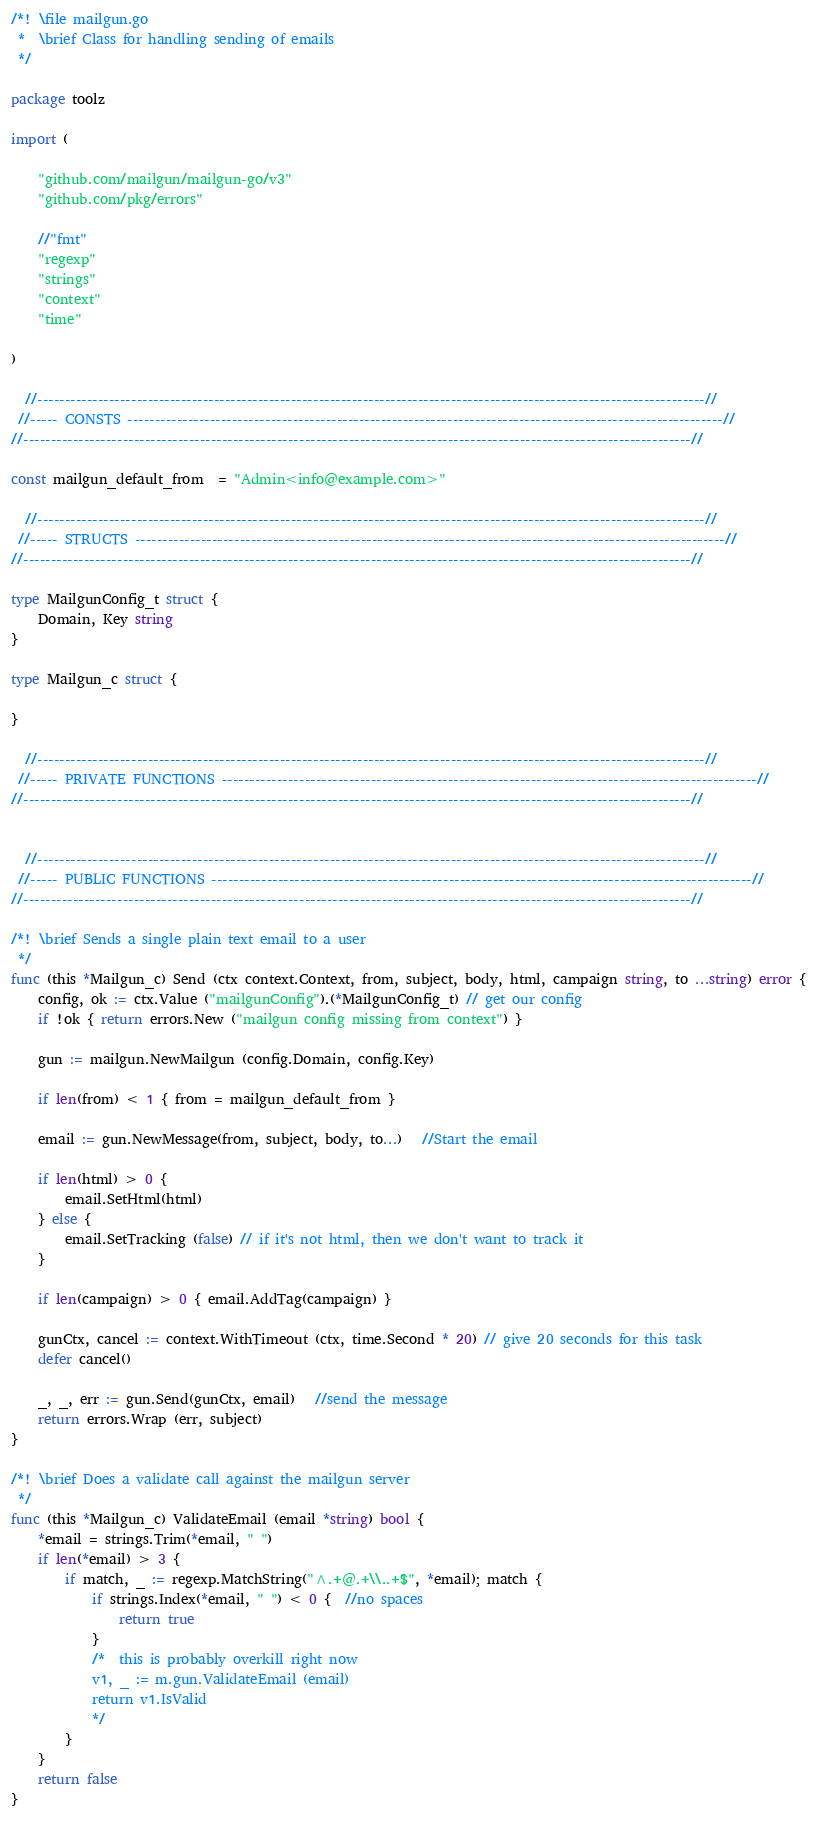Convert code to text. <code><loc_0><loc_0><loc_500><loc_500><_Go_>/*! \file mailgun.go
 *  \brief Class for handling sending of emails
 */

package toolz

import (

	"github.com/mailgun/mailgun-go/v3"
	"github.com/pkg/errors"

    //"fmt"
    "regexp"
	"strings"
	"context"
    "time"
    
)

  //-------------------------------------------------------------------------------------------------------------------------//
 //----- CONSTS ------------------------------------------------------------------------------------------------------------//
//-------------------------------------------------------------------------------------------------------------------------//

const mailgun_default_from  = "Admin<info@example.com>"

  //-------------------------------------------------------------------------------------------------------------------------//
 //----- STRUCTS -----------------------------------------------------------------------------------------------------------//
//-------------------------------------------------------------------------------------------------------------------------//

type MailgunConfig_t struct {
	Domain, Key string
}

type Mailgun_c struct {
    
}

  //-------------------------------------------------------------------------------------------------------------------------//
 //----- PRIVATE FUNCTIONS -------------------------------------------------------------------------------------------------//
//-------------------------------------------------------------------------------------------------------------------------//


  //-------------------------------------------------------------------------------------------------------------------------//
 //----- PUBLIC FUNCTIONS --------------------------------------------------------------------------------------------------//
//-------------------------------------------------------------------------------------------------------------------------//

/*! \brief Sends a single plain text email to a user
 */
func (this *Mailgun_c) Send (ctx context.Context, from, subject, body, html, campaign string, to ...string) error {
	config, ok := ctx.Value ("mailgunConfig").(*MailgunConfig_t) // get our config
	if !ok { return errors.New ("mailgun config missing from context") }

	gun := mailgun.NewMailgun (config.Domain, config.Key)

    if len(from) < 1 { from = mailgun_default_from }
    
	email := gun.NewMessage(from, subject, body, to...)   //Start the email
	
	if len(html) > 0 { 
		email.SetHtml(html) 
	} else {
		email.SetTracking (false) // if it's not html, then we don't want to track it
	}
    
	if len(campaign) > 0 { email.AddTag(campaign) }
	
	gunCtx, cancel := context.WithTimeout (ctx, time.Second * 20) // give 20 seconds for this task
	defer cancel()
    
	_, _, err := gun.Send(gunCtx, email)   //send the message
	return errors.Wrap (err, subject)
}

/*! \brief Does a validate call against the mailgun server
 */
func (this *Mailgun_c) ValidateEmail (email *string) bool {
    *email = strings.Trim(*email, " ")
    if len(*email) > 3 {
        if match, _ := regexp.MatchString("^.+@.+\\..+$", *email); match {
			if strings.Index(*email, " ") < 0 {  //no spaces
				return true
			}
			/*  this is probably overkill right now
			v1, _ := m.gun.ValidateEmail (email)
			return v1.IsValid
			*/
        }
    }
    return false
}</code> 